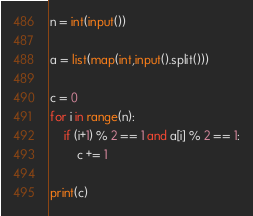Convert code to text. <code><loc_0><loc_0><loc_500><loc_500><_Python_>n = int(input())

a = list(map(int,input().split()))

c = 0
for i in range(n):
    if (i+1) % 2 == 1 and a[i] % 2 == 1:
        c += 1

print(c)
</code> 